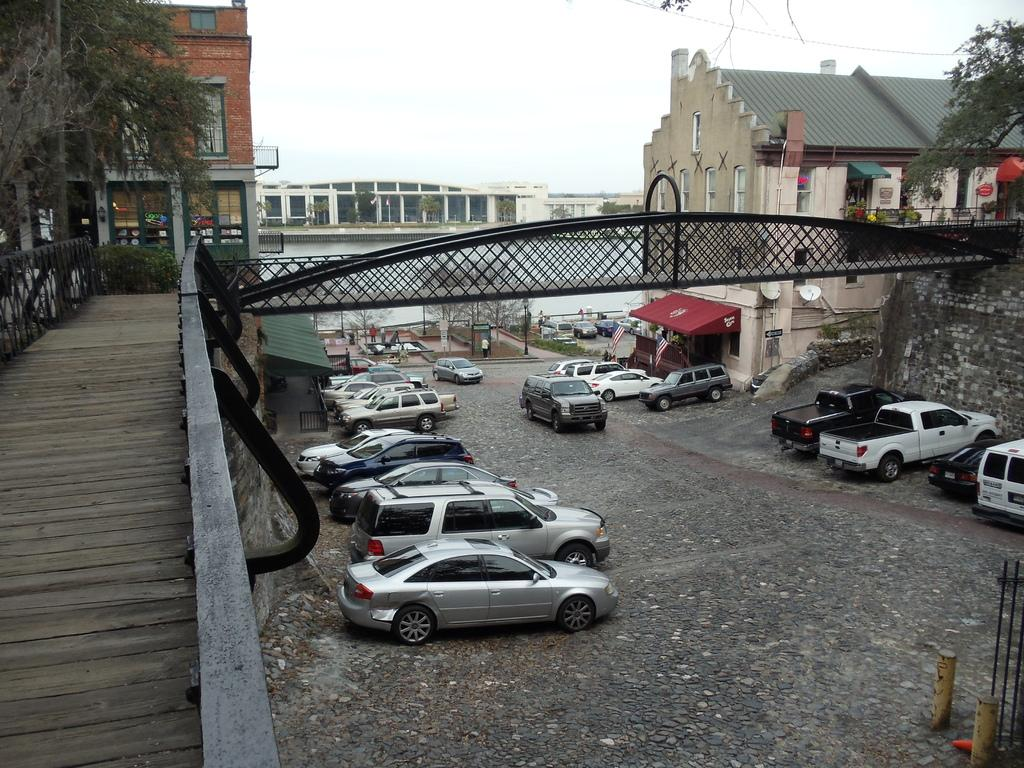What is the main structure in the foreground of the image? There is a bridge in the foreground of the image. What type of vehicles can be seen on the road? There are fleets of cars on the road. What natural elements are present in the image? Trees and water are visible in the image. What type of man-made structures can be seen in the image? There are buildings in the image. What is visible at the top of the image? The sky is visible at the top of the image. What time of day is the image likely taken? The image is likely taken during the day, as the sky is visible and there are no indications of darkness. What type of error can be seen in the image? There is no error present in the image; it appears to be a clear and accurate representation of the scene. 